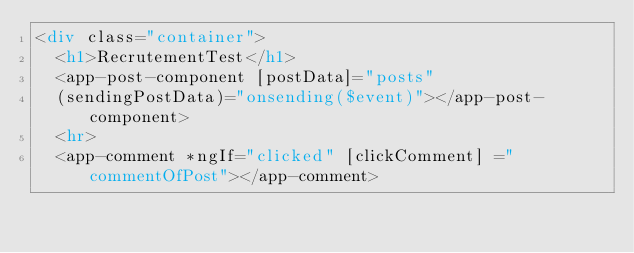<code> <loc_0><loc_0><loc_500><loc_500><_HTML_><div class="container">
  <h1>RecrutementTest</h1>
  <app-post-component [postData]="posts" 
  (sendingPostData)="onsending($event)"></app-post-component>
  <hr>
  <app-comment *ngIf="clicked" [clickComment] ="commentOfPost"></app-comment>


</code> 